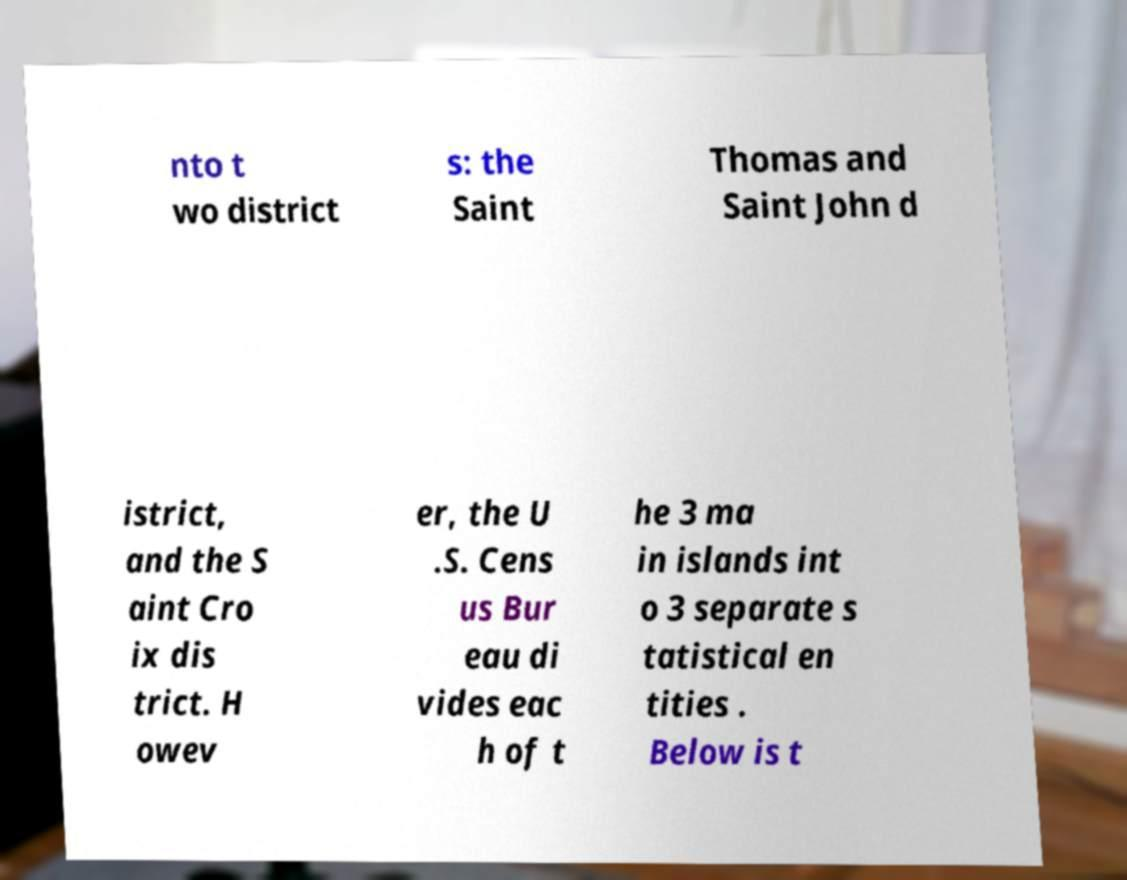For documentation purposes, I need the text within this image transcribed. Could you provide that? nto t wo district s: the Saint Thomas and Saint John d istrict, and the S aint Cro ix dis trict. H owev er, the U .S. Cens us Bur eau di vides eac h of t he 3 ma in islands int o 3 separate s tatistical en tities . Below is t 